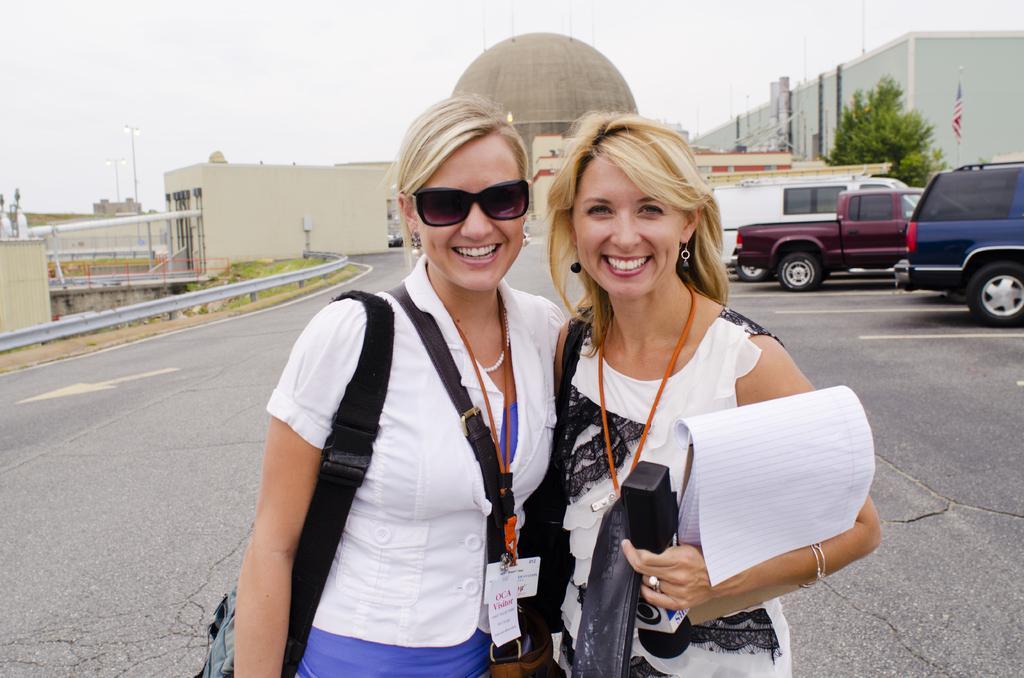In one or two sentences, can you explain what this image depicts? There are two women standing and smiling. This woman is holding a mike and a book in her hands. These are the badges. This looks like a bag. I can see a van, truck and a car, which are parked. These are the buildings. This is the road. I can see a tree. This looks like a flag, which is hanging to the pole. 